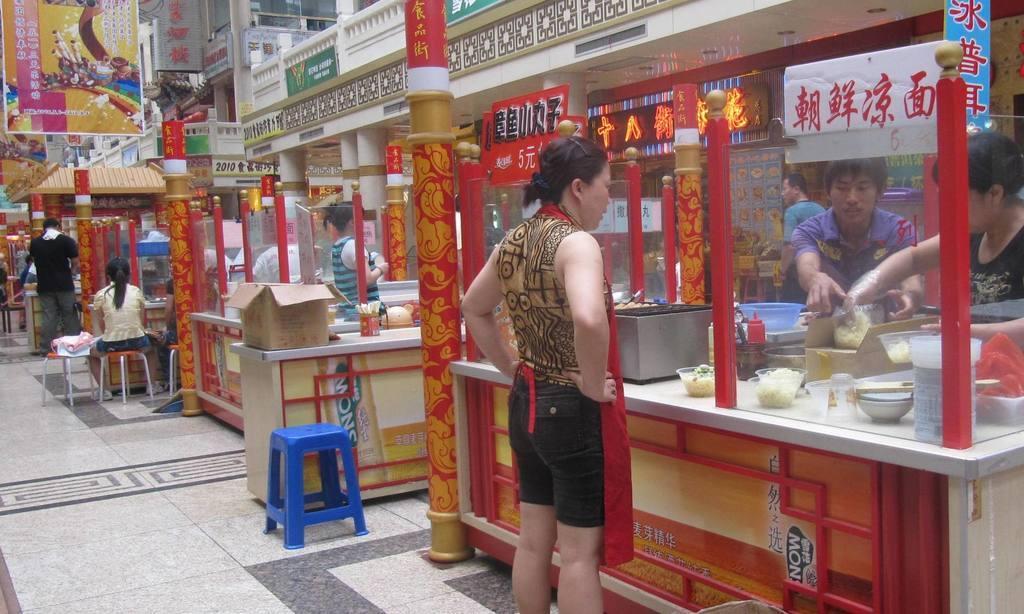Could you give a brief overview of what you see in this image? In this image there are some stalls and some persons are standing, in the stalls there are some popcorns, stoves, bowls, sauce bottles, clothes, box and some other objects. And in the center there are some stools, in the background there are some boards, pillars, buildings. On the boards there is text, at the bottom there is floor. 